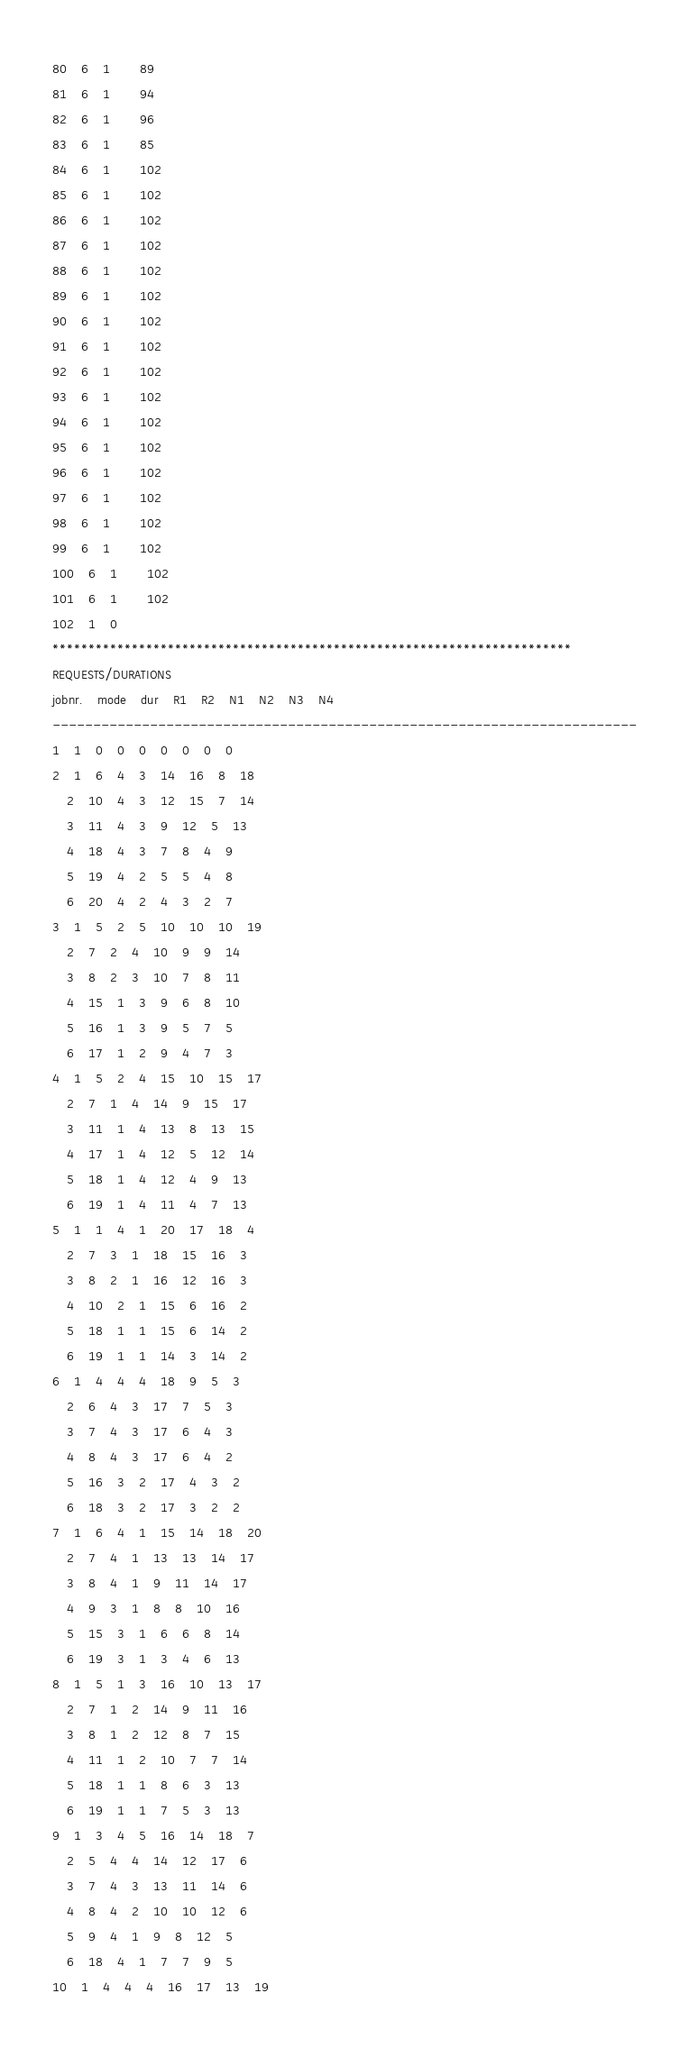<code> <loc_0><loc_0><loc_500><loc_500><_ObjectiveC_>80	6	1		89 
81	6	1		94 
82	6	1		96 
83	6	1		85 
84	6	1		102 
85	6	1		102 
86	6	1		102 
87	6	1		102 
88	6	1		102 
89	6	1		102 
90	6	1		102 
91	6	1		102 
92	6	1		102 
93	6	1		102 
94	6	1		102 
95	6	1		102 
96	6	1		102 
97	6	1		102 
98	6	1		102 
99	6	1		102 
100	6	1		102 
101	6	1		102 
102	1	0		
************************************************************************
REQUESTS/DURATIONS
jobnr.	mode	dur	R1	R2	N1	N2	N3	N4	
------------------------------------------------------------------------
1	1	0	0	0	0	0	0	0	
2	1	6	4	3	14	16	8	18	
	2	10	4	3	12	15	7	14	
	3	11	4	3	9	12	5	13	
	4	18	4	3	7	8	4	9	
	5	19	4	2	5	5	4	8	
	6	20	4	2	4	3	2	7	
3	1	5	2	5	10	10	10	19	
	2	7	2	4	10	9	9	14	
	3	8	2	3	10	7	8	11	
	4	15	1	3	9	6	8	10	
	5	16	1	3	9	5	7	5	
	6	17	1	2	9	4	7	3	
4	1	5	2	4	15	10	15	17	
	2	7	1	4	14	9	15	17	
	3	11	1	4	13	8	13	15	
	4	17	1	4	12	5	12	14	
	5	18	1	4	12	4	9	13	
	6	19	1	4	11	4	7	13	
5	1	1	4	1	20	17	18	4	
	2	7	3	1	18	15	16	3	
	3	8	2	1	16	12	16	3	
	4	10	2	1	15	6	16	2	
	5	18	1	1	15	6	14	2	
	6	19	1	1	14	3	14	2	
6	1	4	4	4	18	9	5	3	
	2	6	4	3	17	7	5	3	
	3	7	4	3	17	6	4	3	
	4	8	4	3	17	6	4	2	
	5	16	3	2	17	4	3	2	
	6	18	3	2	17	3	2	2	
7	1	6	4	1	15	14	18	20	
	2	7	4	1	13	13	14	17	
	3	8	4	1	9	11	14	17	
	4	9	3	1	8	8	10	16	
	5	15	3	1	6	6	8	14	
	6	19	3	1	3	4	6	13	
8	1	5	1	3	16	10	13	17	
	2	7	1	2	14	9	11	16	
	3	8	1	2	12	8	7	15	
	4	11	1	2	10	7	7	14	
	5	18	1	1	8	6	3	13	
	6	19	1	1	7	5	3	13	
9	1	3	4	5	16	14	18	7	
	2	5	4	4	14	12	17	6	
	3	7	4	3	13	11	14	6	
	4	8	4	2	10	10	12	6	
	5	9	4	1	9	8	12	5	
	6	18	4	1	7	7	9	5	
10	1	4	4	4	16	17	13	19	</code> 